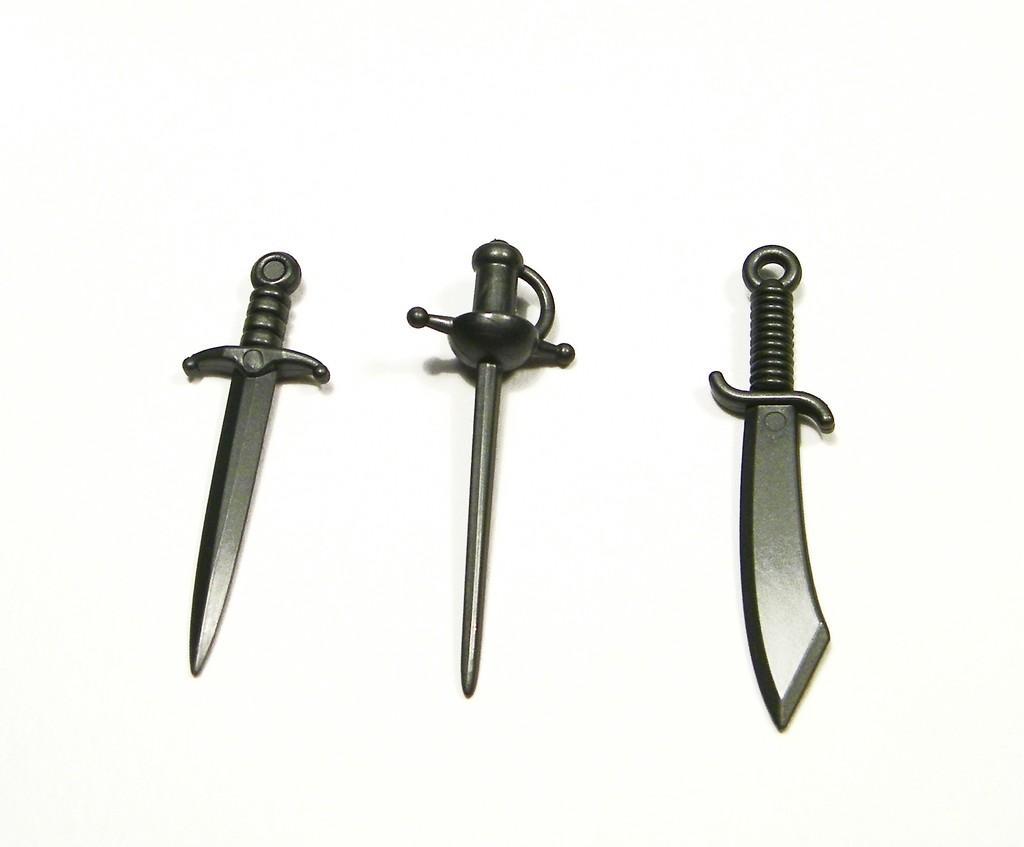Could you give a brief overview of what you see in this image? In the picture we can see three words which are black and gray in color. 